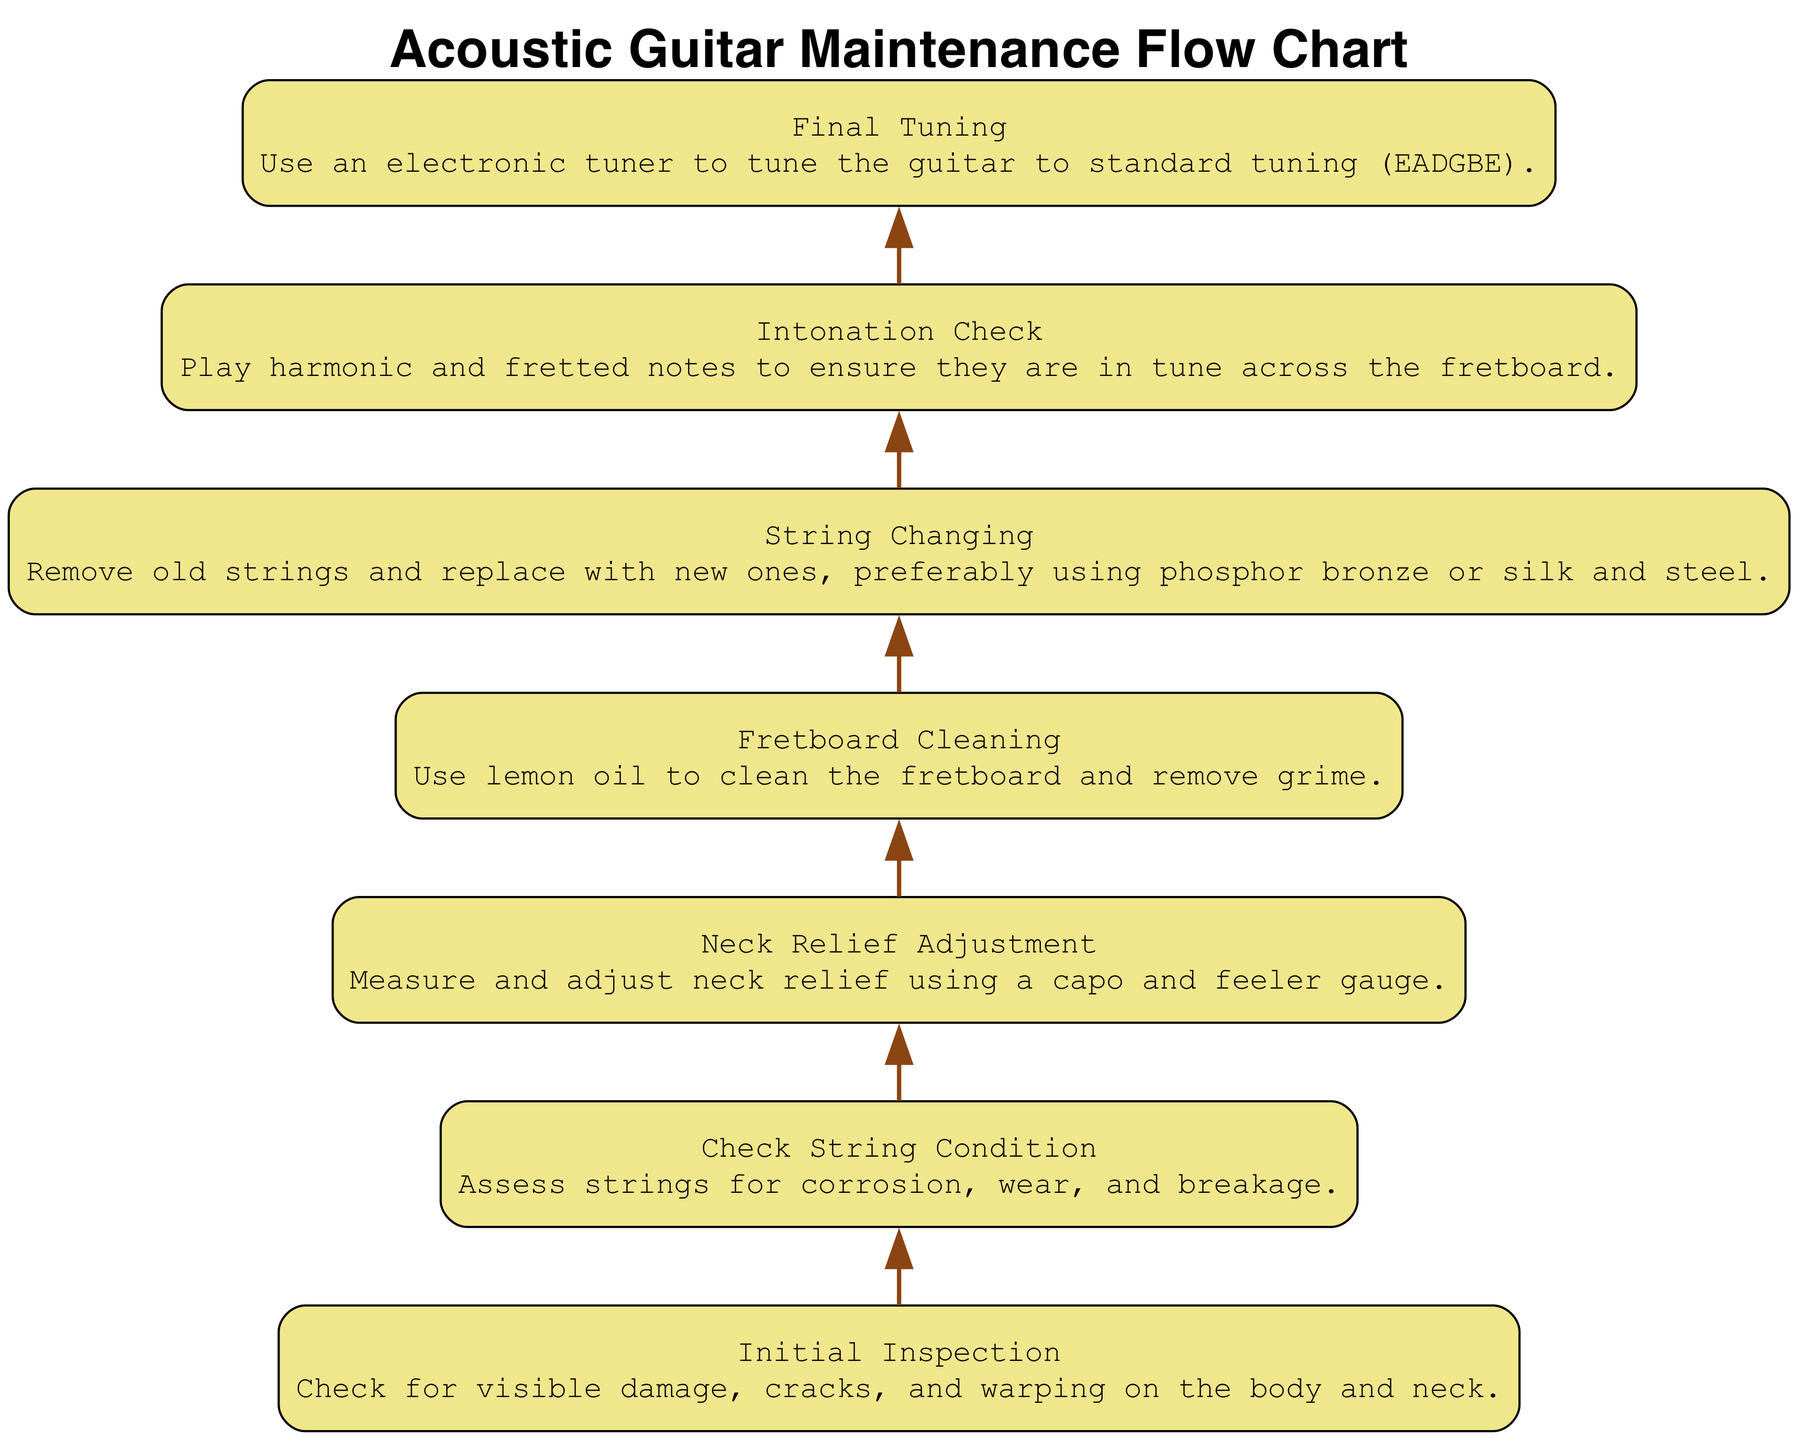What is the first task in the maintenance process? The diagram starts with the "Initial Inspection" node, indicating that this is the first task in maintaining an acoustic guitar.
Answer: Initial Inspection What follows "Check String Condition"? In the flow chart, "Neck Relief Adjustment" follows the "Check String Condition" node, indicating the sequence of tasks in the maintenance process.
Answer: Neck Relief Adjustment How many tasks are included in the maintenance overview? By counting the nodes in the diagram, there are a total of 7 tasks outlined in the maintenance process, such as "Initial Inspection" and "Final Tuning."
Answer: 7 What maintenance task involves using lemon oil? The "Fretboard Cleaning" task specifically mentions using lemon oil for cleaning the fretboard, highlighting a unique aspect of the maintenance process.
Answer: Fretboard Cleaning What is the last step before final tuning? The diagram shows that "Intonation Check" occurs just prior to "Final Tuning," indicating the penultimate task in the sequence.
Answer: Intonation Check Which task directly follows "String Changing"? According to the diagram, "Intonation Check" is the task that directly follows "String Changing," reflecting the order of maintenance activities.
Answer: Intonation Check What is the primary goal of the initial inspection? The initial inspection aims to examine for visible damage, cracks, and warping, serving as a crucial starting point in the maintenance overview.
Answer: Check for visible damage What does neck relief adjustment require? The task "Neck Relief Adjustment" requires measuring and adjusting neck relief using a capo and feeler gauge, indicating specific tools and methods involved.
Answer: Capo and feeler gauge What is the description for string changing? The task "String Changing" is described as removing old strings and replacing them with new ones, specifying the types of strings to prefer.
Answer: Remove old strings and replace with new ones 